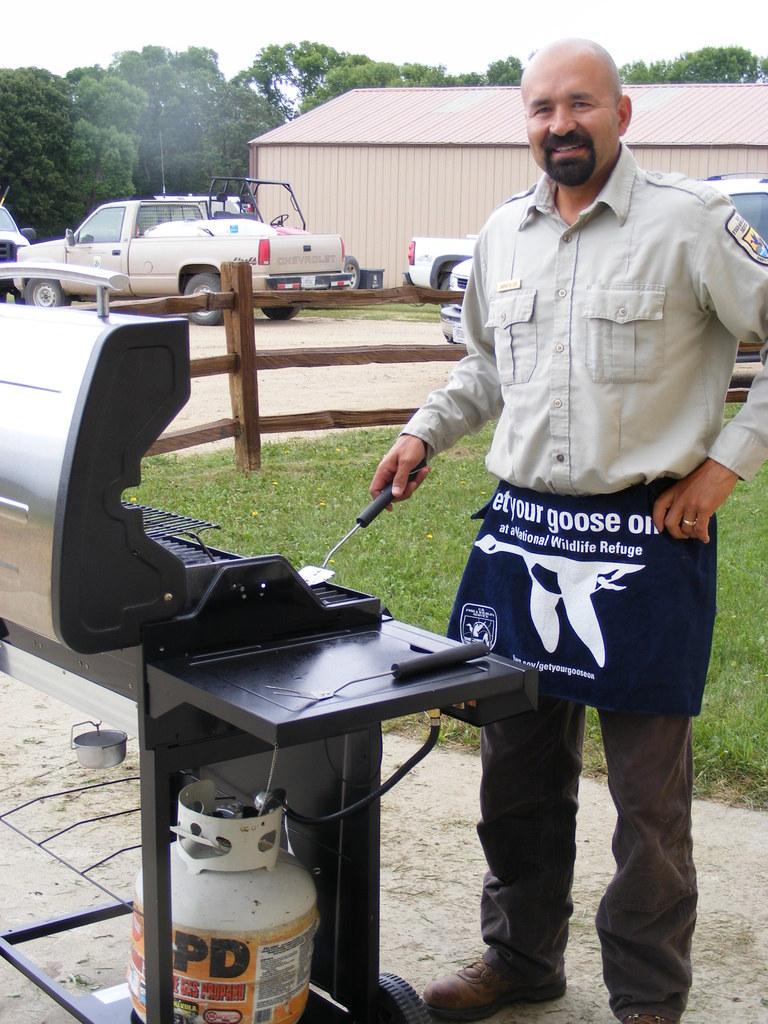What is there a picture of on his apron?
Give a very brief answer. Goose. Name the black letters on the tank?
Offer a very short reply. Pd. 